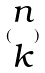<formula> <loc_0><loc_0><loc_500><loc_500>( \begin{matrix} n \\ k \end{matrix} )</formula> 